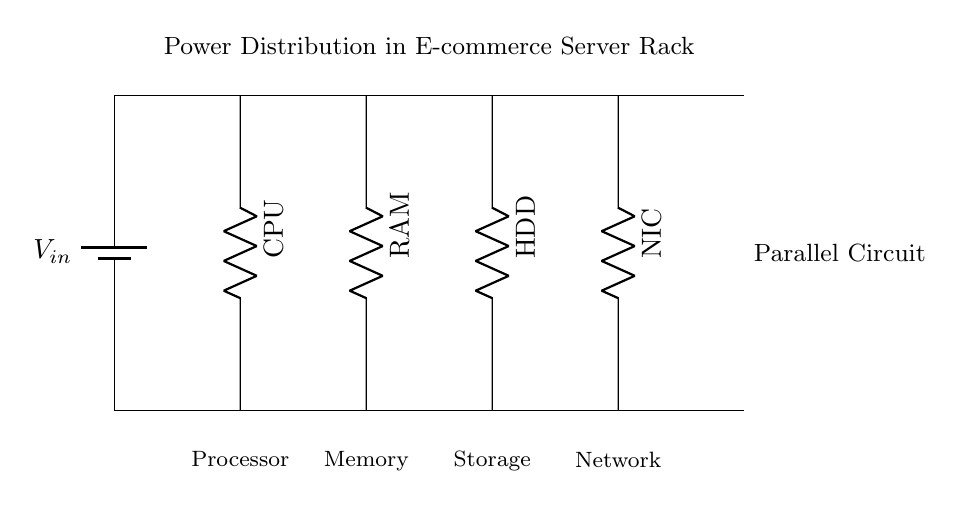What is the input voltage in this circuit? The input voltage is represented as V_in, which is directly connected to the battery symbol in the diagram.
Answer: V_in What components are powered by the circuit? The circuit includes four primary components: the CPU, RAM, HDD, and NIC. Each of these components is represented by a resistor symbol connected down from the main bus, indicating they are powered by the same voltage source.
Answer: CPU, RAM, HDD, NIC How is power distributed in this circuit? Power is distributed in a parallel configuration, meaning that each component is connected directly to the same voltage source, allowing equal voltage across each component while independent voltage drops can occur.
Answer: Parallel What is the main characteristic of a parallel circuit shown here? The main characteristic is that each component receives the same voltage while allowing for multiple paths for current flow. This is evident since all components share the same voltage source and bus.
Answer: Same voltage What would happen if one component fails in this configuration? If one component fails, the other components would continue to operate unaffected. This is a key advantage of parallel circuits, as it allows the other devices to maintain functionality.
Answer: Others continue How many total components are connected to the power source? There are four components connected to the power source as shown by the four resistors vertically aligned beneath the main bus, each representing a different server component.
Answer: Four 